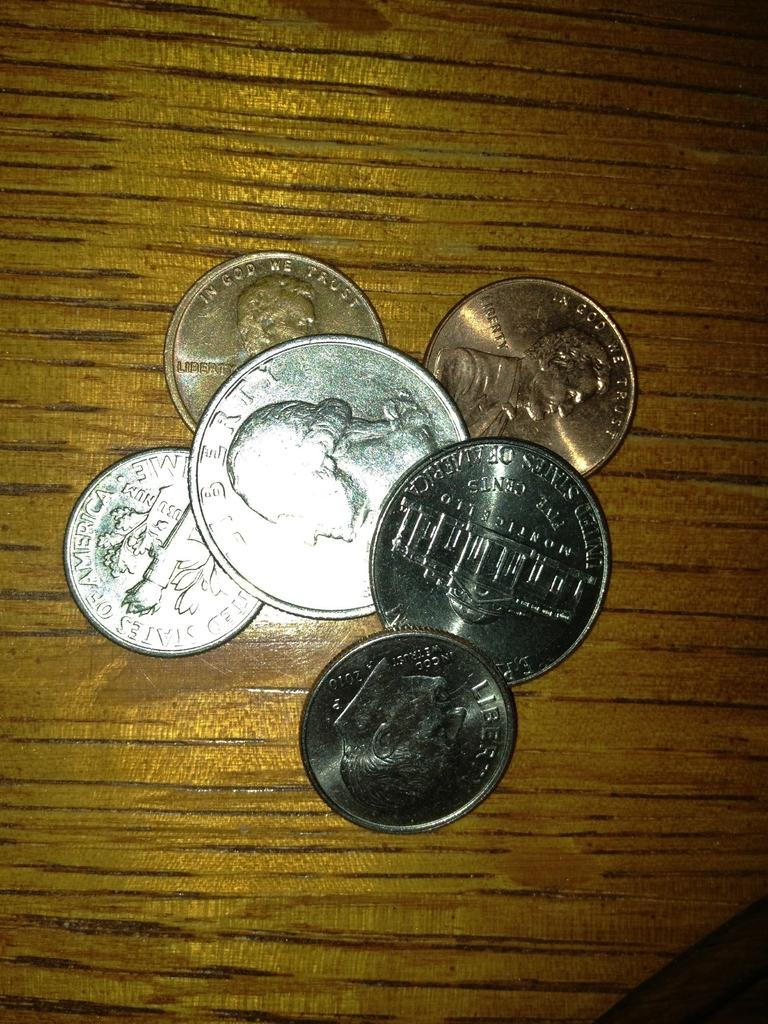<image>
Render a clear and concise summary of the photo. American coins reading Liberty and In God We Trust on a table 